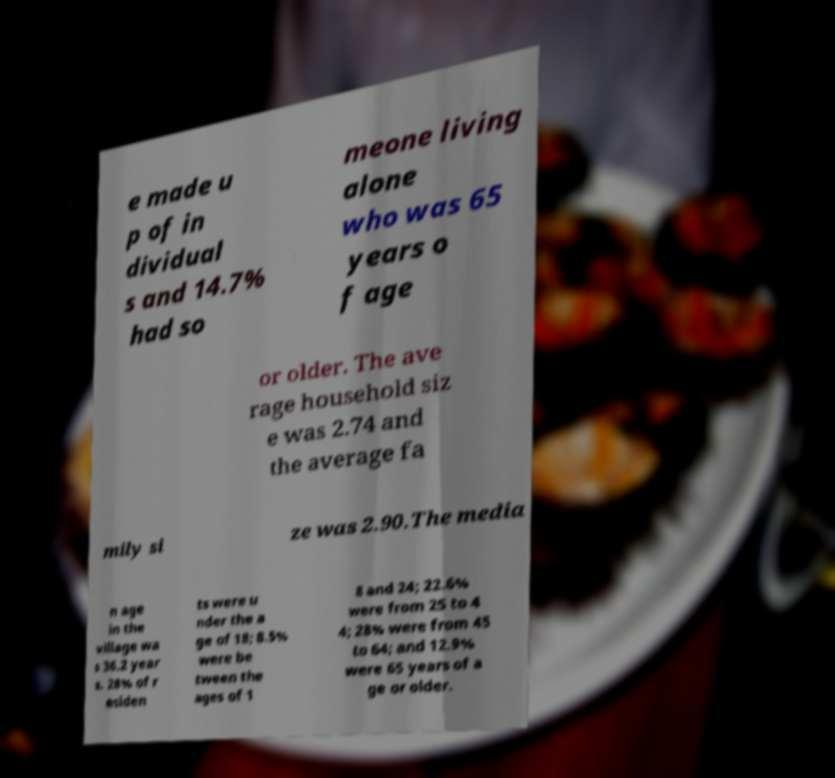Can you accurately transcribe the text from the provided image for me? e made u p of in dividual s and 14.7% had so meone living alone who was 65 years o f age or older. The ave rage household siz e was 2.74 and the average fa mily si ze was 2.90.The media n age in the village wa s 36.2 year s. 28% of r esiden ts were u nder the a ge of 18; 8.5% were be tween the ages of 1 8 and 24; 22.6% were from 25 to 4 4; 28% were from 45 to 64; and 12.9% were 65 years of a ge or older. 